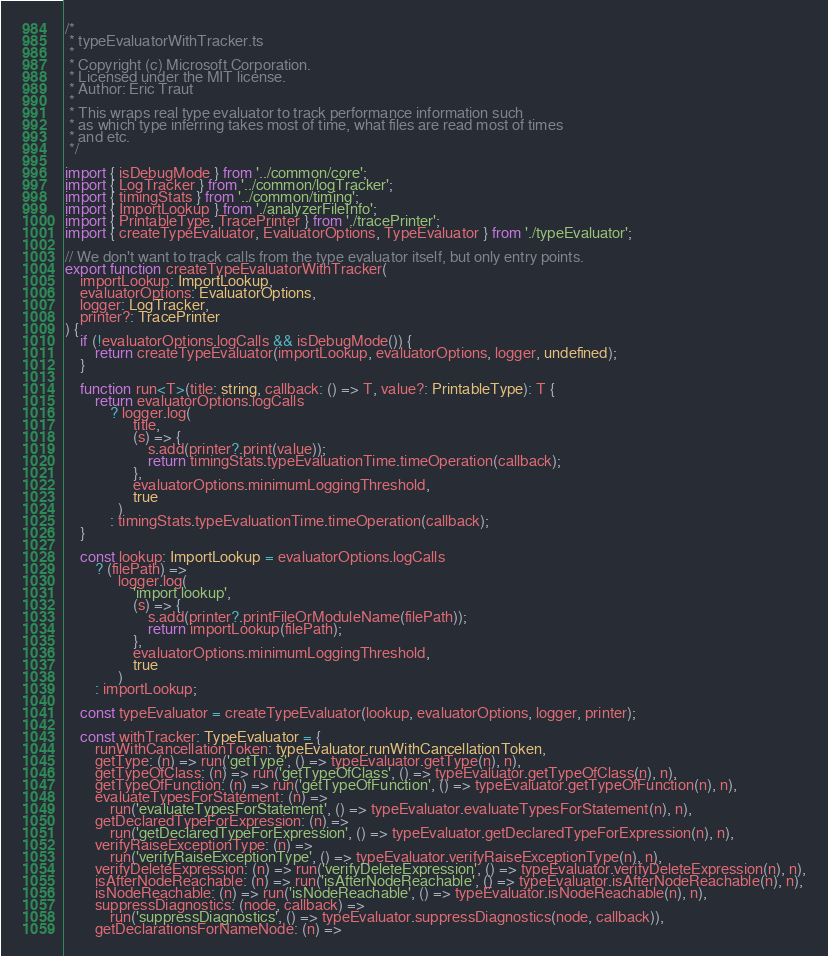<code> <loc_0><loc_0><loc_500><loc_500><_TypeScript_>/*
 * typeEvaluatorWithTracker.ts
 *
 * Copyright (c) Microsoft Corporation.
 * Licensed under the MIT license.
 * Author: Eric Traut
 *
 * This wraps real type evaluator to track performance information such
 * as which type inferring takes most of time, what files are read most of times
 * and etc.
 */

import { isDebugMode } from '../common/core';
import { LogTracker } from '../common/logTracker';
import { timingStats } from '../common/timing';
import { ImportLookup } from './analyzerFileInfo';
import { PrintableType, TracePrinter } from './tracePrinter';
import { createTypeEvaluator, EvaluatorOptions, TypeEvaluator } from './typeEvaluator';

// We don't want to track calls from the type evaluator itself, but only entry points.
export function createTypeEvaluatorWithTracker(
    importLookup: ImportLookup,
    evaluatorOptions: EvaluatorOptions,
    logger: LogTracker,
    printer?: TracePrinter
) {
    if (!evaluatorOptions.logCalls && isDebugMode()) {
        return createTypeEvaluator(importLookup, evaluatorOptions, logger, undefined);
    }

    function run<T>(title: string, callback: () => T, value?: PrintableType): T {
        return evaluatorOptions.logCalls
            ? logger.log(
                  title,
                  (s) => {
                      s.add(printer?.print(value));
                      return timingStats.typeEvaluationTime.timeOperation(callback);
                  },
                  evaluatorOptions.minimumLoggingThreshold,
                  true
              )
            : timingStats.typeEvaluationTime.timeOperation(callback);
    }

    const lookup: ImportLookup = evaluatorOptions.logCalls
        ? (filePath) =>
              logger.log(
                  'import lookup',
                  (s) => {
                      s.add(printer?.printFileOrModuleName(filePath));
                      return importLookup(filePath);
                  },
                  evaluatorOptions.minimumLoggingThreshold,
                  true
              )
        : importLookup;

    const typeEvaluator = createTypeEvaluator(lookup, evaluatorOptions, logger, printer);

    const withTracker: TypeEvaluator = {
        runWithCancellationToken: typeEvaluator.runWithCancellationToken,
        getType: (n) => run('getType', () => typeEvaluator.getType(n), n),
        getTypeOfClass: (n) => run('getTypeOfClass', () => typeEvaluator.getTypeOfClass(n), n),
        getTypeOfFunction: (n) => run('getTypeOfFunction', () => typeEvaluator.getTypeOfFunction(n), n),
        evaluateTypesForStatement: (n) =>
            run('evaluateTypesForStatement', () => typeEvaluator.evaluateTypesForStatement(n), n),
        getDeclaredTypeForExpression: (n) =>
            run('getDeclaredTypeForExpression', () => typeEvaluator.getDeclaredTypeForExpression(n), n),
        verifyRaiseExceptionType: (n) =>
            run('verifyRaiseExceptionType', () => typeEvaluator.verifyRaiseExceptionType(n), n),
        verifyDeleteExpression: (n) => run('verifyDeleteExpression', () => typeEvaluator.verifyDeleteExpression(n), n),
        isAfterNodeReachable: (n) => run('isAfterNodeReachable', () => typeEvaluator.isAfterNodeReachable(n), n),
        isNodeReachable: (n) => run('isNodeReachable', () => typeEvaluator.isNodeReachable(n), n),
        suppressDiagnostics: (node, callback) =>
            run('suppressDiagnostics', () => typeEvaluator.suppressDiagnostics(node, callback)),
        getDeclarationsForNameNode: (n) =></code> 